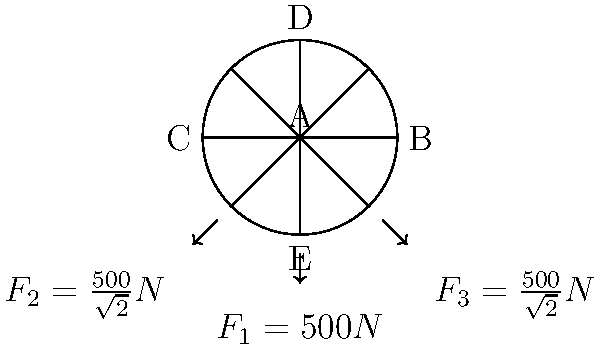An ornate art deco chandelier in your luxury hotel's grand ballroom is modeled as a planar structure with a central hub (A) and four arms (AB, AC, AD, AE) as shown in the diagram. The chandelier is subjected to three downward forces: $F_1 = 500N$ at point E, and $F_2 = F_3 = \frac{500}{\sqrt{2}}N$ at the ends of the diagonal arms. Assuming the structure is in equilibrium, determine the magnitude of the reaction force at point A. To solve this problem, we'll use the principles of static equilibrium. The steps are as follows:

1) First, we need to identify that for a structure to be in equilibrium, the sum of all forces must be zero.

   $$\sum F_x = 0 \quad \text{and} \quad \sum F_y = 0$$

2) In this case, we only have vertical forces (in the y-direction), so we'll focus on $\sum F_y = 0$.

3) Let's denote the reaction force at A as $R_A$. This force will be upward (positive) to balance the downward forces.

4) Now, we can write the equation for vertical equilibrium:

   $$R_A - F_1 - F_2 - F_3 = 0$$

5) Substituting the known values:

   $$R_A - 500 - \frac{500}{\sqrt{2}} - \frac{500}{\sqrt{2}} = 0$$

6) Simplifying:

   $$R_A - 500 - \frac{1000}{\sqrt{2}} = 0$$

7) Solving for $R_A$:

   $$R_A = 500 + \frac{1000}{\sqrt{2}} = 500 + 500\sqrt{2}$$

8) To get the final numerical value:

   $$R_A = 500 + 500 \cdot 1.414 = 1207N$$

Therefore, the magnitude of the reaction force at point A is approximately 1207N.
Answer: 1207N 